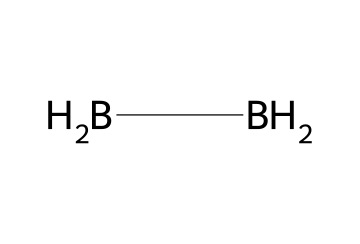What is the molecular formula of diborane? The SMILES representation shows two boron atoms and four hydrogen atoms (two [BH2] units), leading to the formula B2H6.
Answer: B2H6 How many boron atoms are present in diborane? The SMILES representation displays two [BH2] units, which indicates there are two boron atoms in the compound.
Answer: 2 What type of bonding is primarily present in diborane? The structure indicates that diborane has covalent bonding, characterized by electron sharing between atoms, specifically between boron and hydrogen.
Answer: covalent How many hydrogen atoms are connected to each boron atom in diborane? Each boron atom is bonded to two hydrogen atoms as represented by the [BH2] structure, meaning each boron has two hydrogens.
Answer: 2 What unique structural feature does diborane exhibit compared to other boranes? Diborane has a bridge-bonding structure where two hydrogen atoms bridge the two boron atoms, which is a distinctive feature not found in most other boranes.
Answer: bridge-bonding What is the main industrial use of diborane? Diborane is primarily used in semiconductor manufacturing, particularly as a doping agent in the production of certain semiconductor materials.
Answer: semiconductor manufacturing 